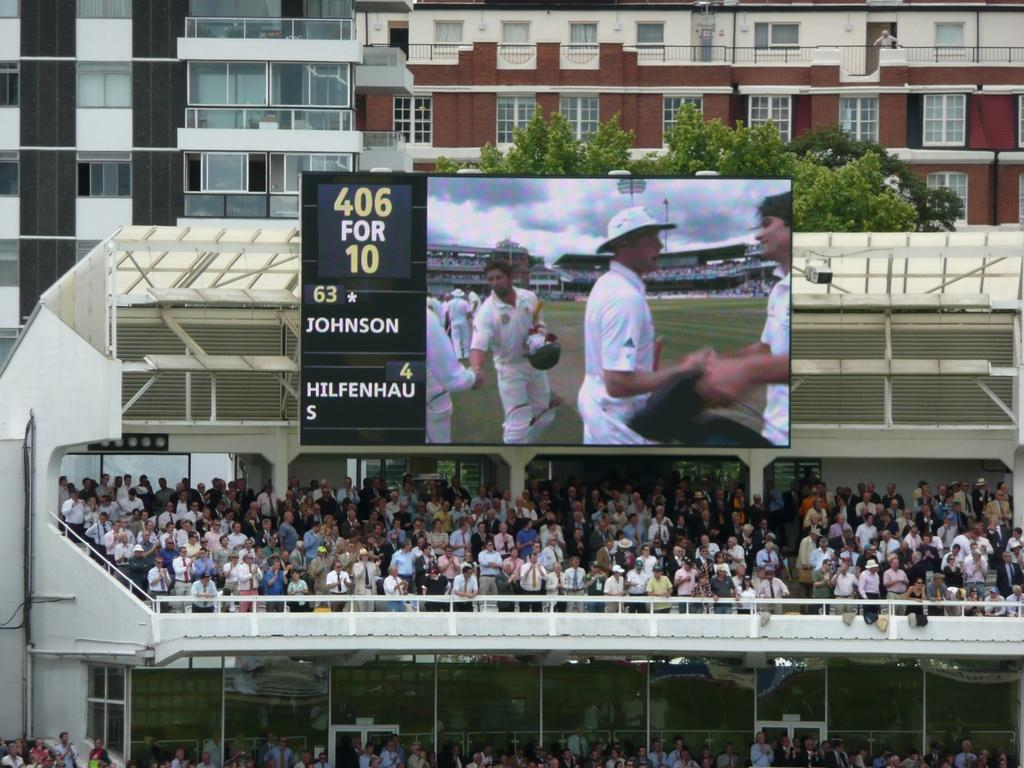Provide a one-sentence caption for the provided image. Spectators at a cricket game where Johnson and Hilfenhaus are playing. 